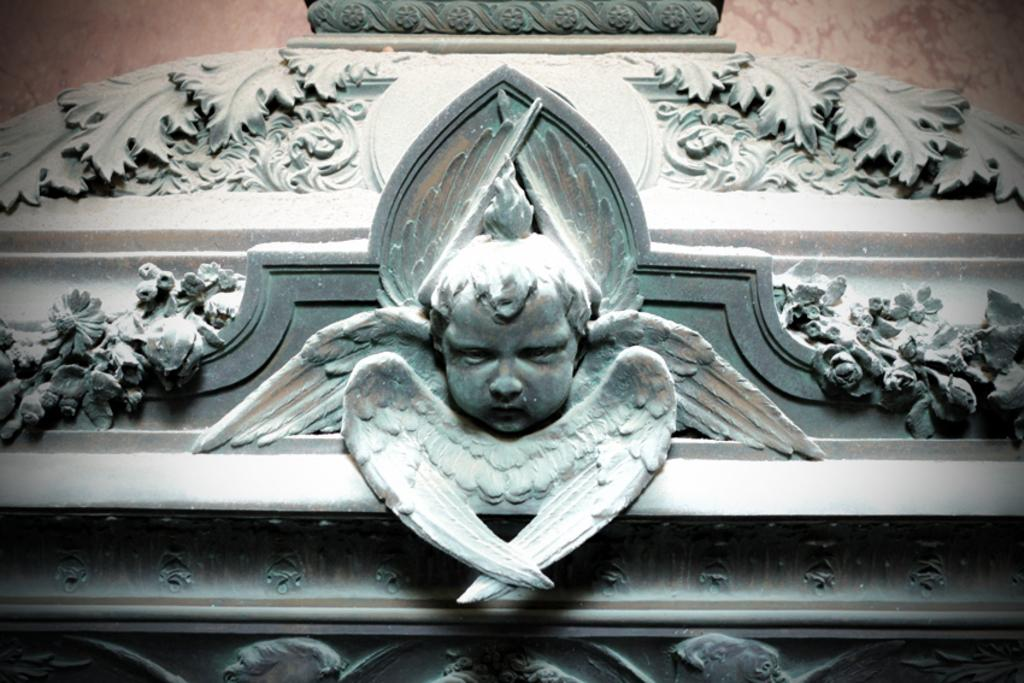What is the main subject of the image? There is a sculpture in the image. Where is the sculpture located in the image? The sculpture is in the center of the image. What type of store can be seen in the background of the image? There is no store present in the image; it features a sculpture in the center. Can you tell me how many rifles are depicted in the image? There are no rifles present in the image; it features a sculpture in the center. 